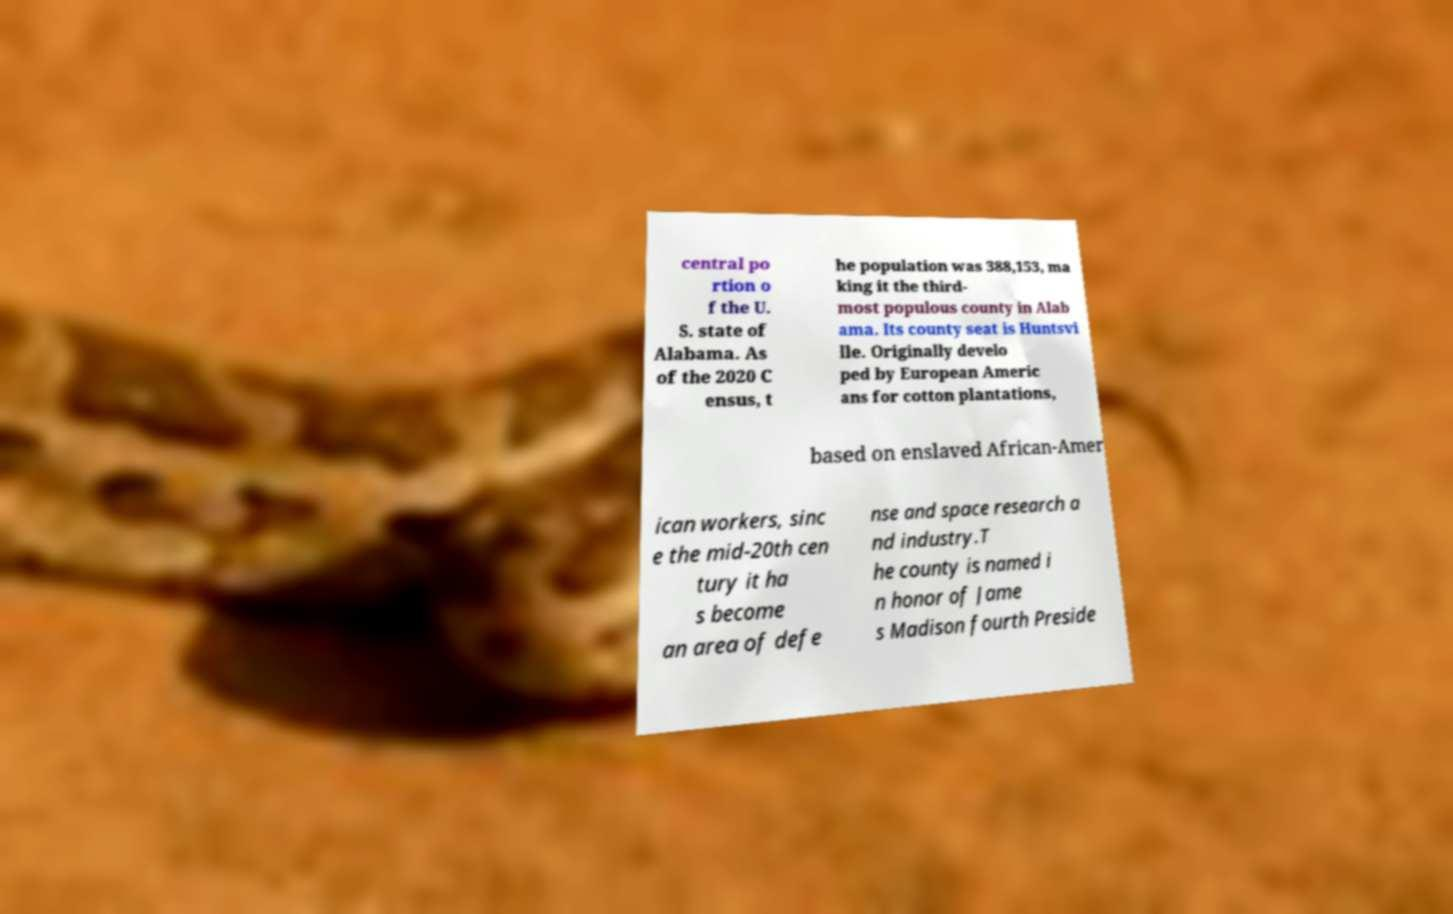Please identify and transcribe the text found in this image. central po rtion o f the U. S. state of Alabama. As of the 2020 C ensus, t he population was 388,153, ma king it the third- most populous county in Alab ama. Its county seat is Huntsvi lle. Originally develo ped by European Americ ans for cotton plantations, based on enslaved African-Amer ican workers, sinc e the mid-20th cen tury it ha s become an area of defe nse and space research a nd industry.T he county is named i n honor of Jame s Madison fourth Preside 